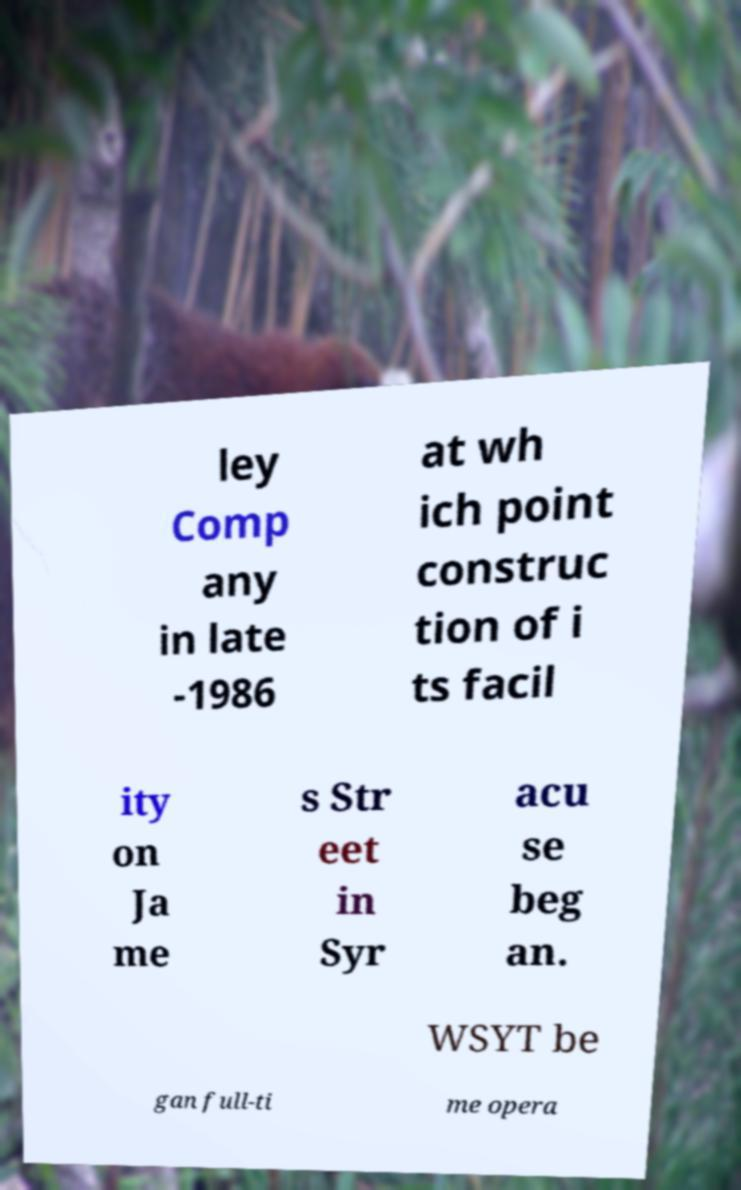Please identify and transcribe the text found in this image. ley Comp any in late -1986 at wh ich point construc tion of i ts facil ity on Ja me s Str eet in Syr acu se beg an. WSYT be gan full-ti me opera 